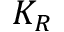Convert formula to latex. <formula><loc_0><loc_0><loc_500><loc_500>K _ { R }</formula> 